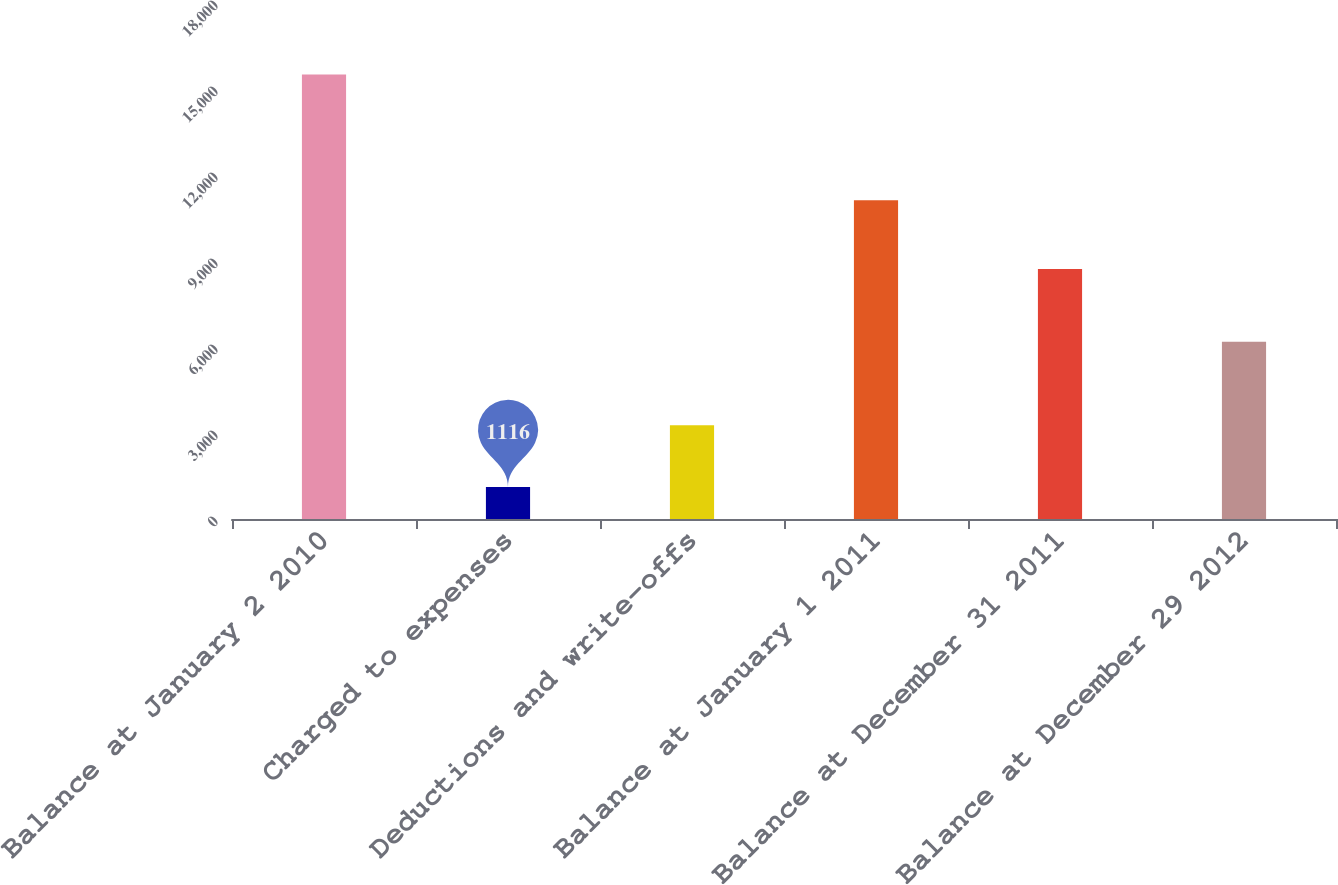Convert chart to OTSL. <chart><loc_0><loc_0><loc_500><loc_500><bar_chart><fcel>Balance at January 2 2010<fcel>Charged to expenses<fcel>Deductions and write-offs<fcel>Balance at January 1 2011<fcel>Balance at December 31 2011<fcel>Balance at December 29 2012<nl><fcel>15502<fcel>1116<fcel>3270<fcel>11116<fcel>8724<fcel>6187<nl></chart> 